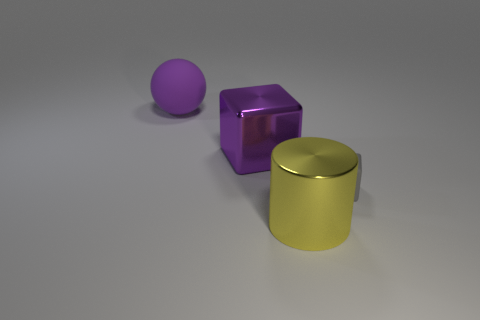The metallic object behind the small gray cube is what color?
Your response must be concise. Purple. Is the shape of the small matte object the same as the metallic object that is behind the large yellow cylinder?
Your answer should be compact. Yes. Are there any big blocks of the same color as the big sphere?
Provide a succinct answer. Yes. There is a purple object that is made of the same material as the tiny gray object; what size is it?
Offer a very short reply. Large. Is the large rubber sphere the same color as the metallic block?
Provide a short and direct response. Yes. There is a shiny object that is behind the gray object; does it have the same shape as the tiny object?
Your answer should be very brief. Yes. What number of rubber cubes have the same size as the purple matte sphere?
Make the answer very short. 0. What shape is the big metal thing that is the same color as the rubber sphere?
Your answer should be very brief. Cube. There is a rubber object on the right side of the big purple matte sphere; are there any rubber things right of it?
Provide a short and direct response. No. How many things are cubes on the right side of the shiny cylinder or yellow matte spheres?
Your response must be concise. 1. 